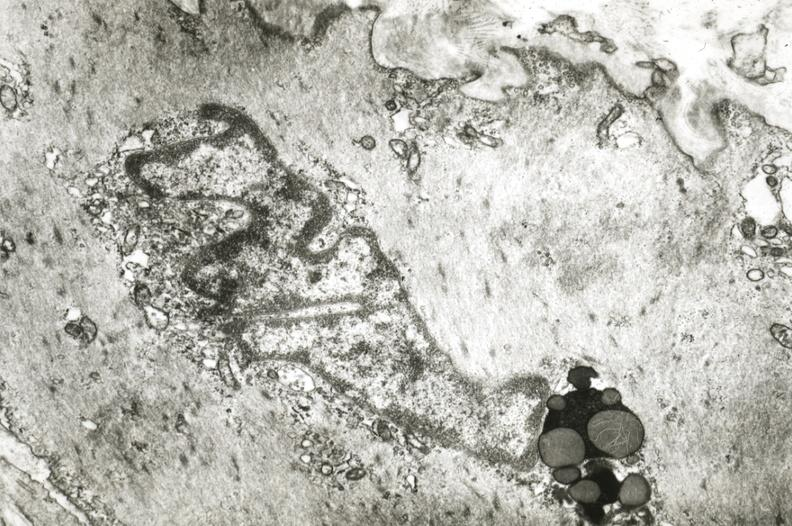what is present?
Answer the question using a single word or phrase. Vasculature 